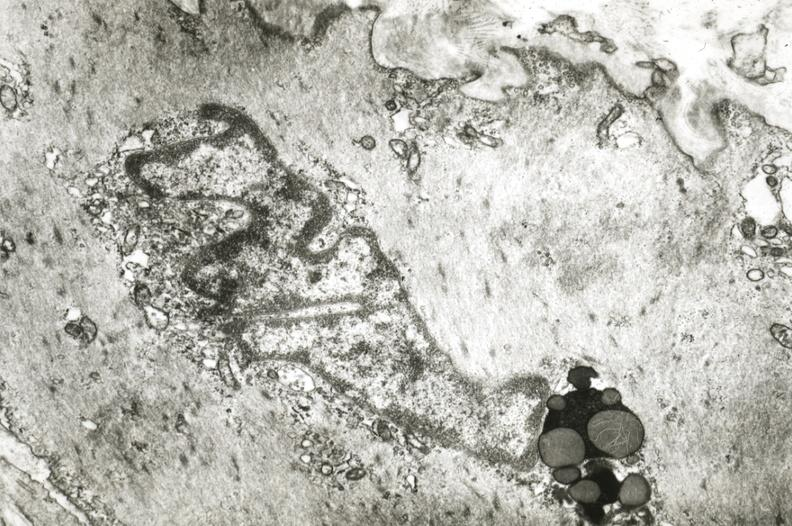what is present?
Answer the question using a single word or phrase. Vasculature 